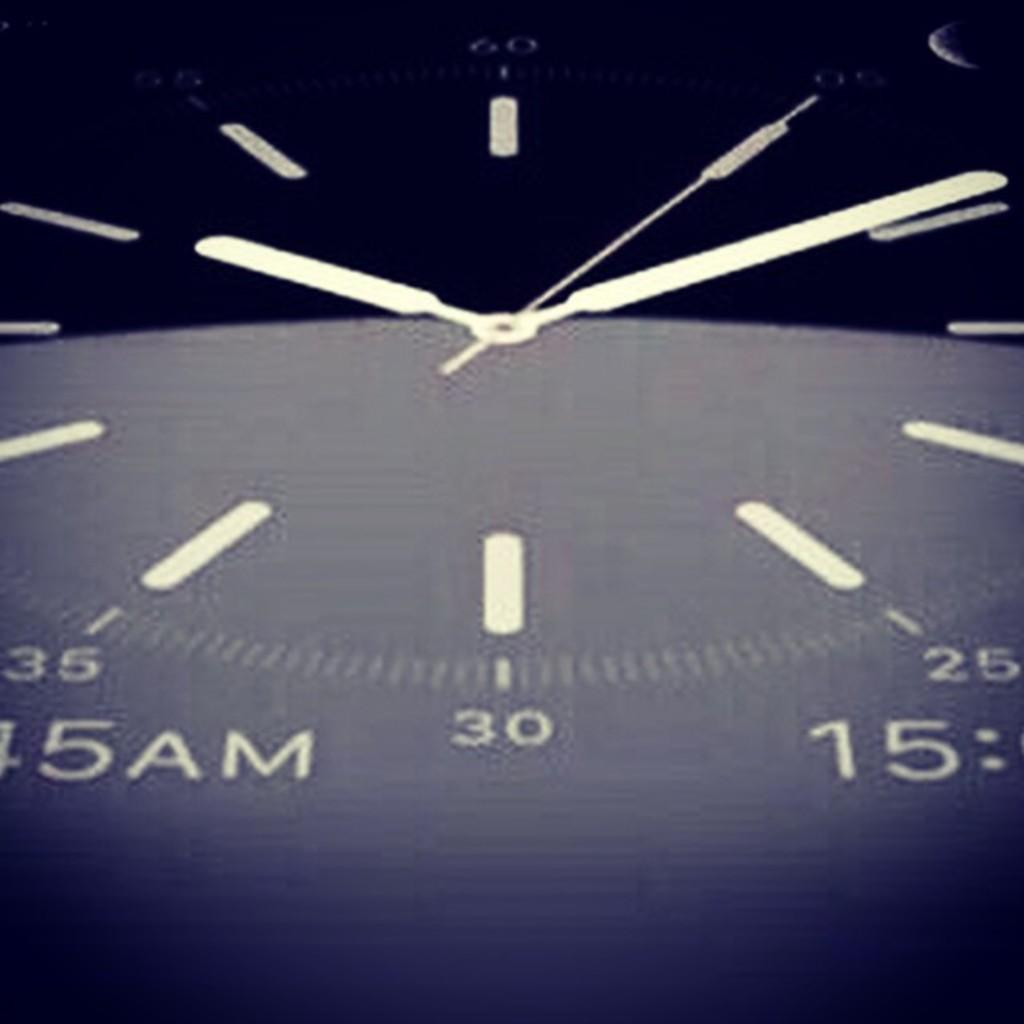<image>
Write a terse but informative summary of the picture. The face of a watch that reads 10:10 on it. 